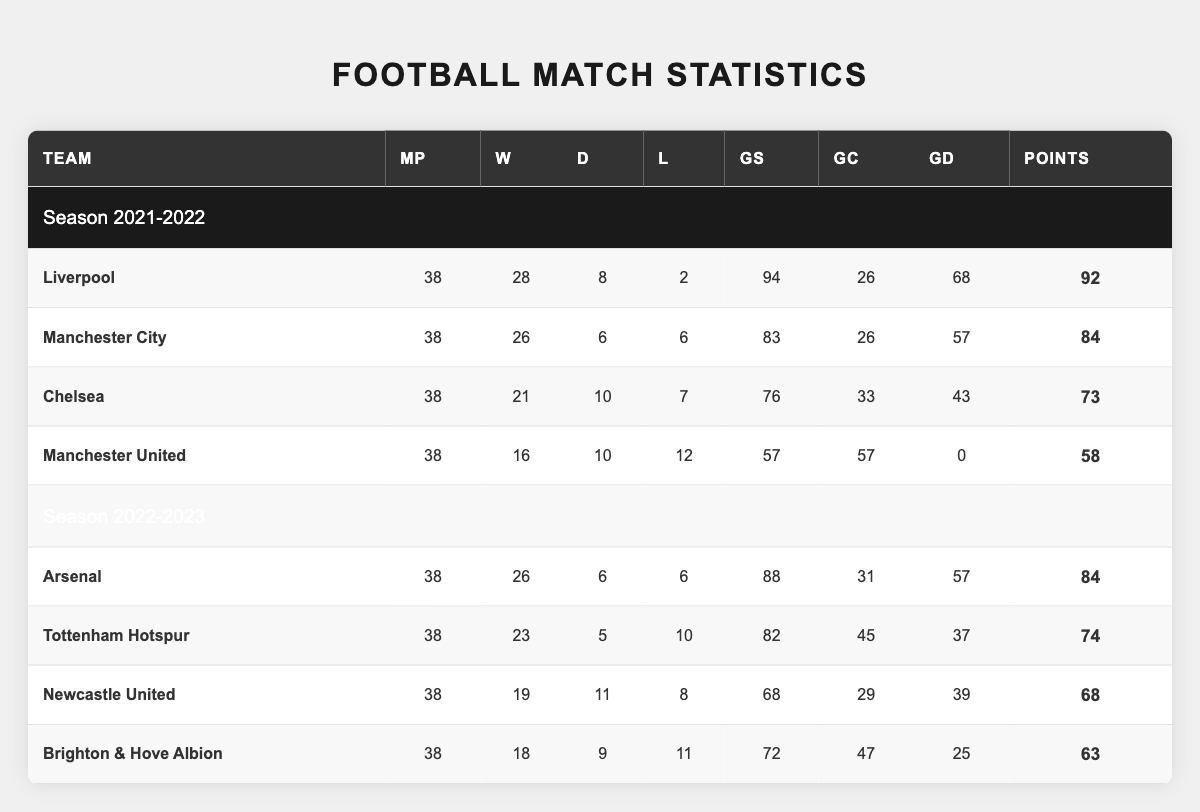What team scored the most goals in the 2021-2022 season? Liverpool scored 94 goals, which is higher than any other team in that season. Looking at the "GoalsScored" column for the 2021-2022 season, Liverpool is the top team.
Answer: Liverpool Which team had the highest points in the 2022-2023 season? Arsenal had 84 points, which is more than the points earned by any other team in the 2022-2023 season. Referring to the "Points" column, Arsenal tops the list for that season.
Answer: Arsenal How many matches did Chelsea play in the 2021-2022 season? Chelsea played 38 matches, as indicated in the "MatchesPlayed" column for that season. Each team's data reflects they played the same number of matches in a full season.
Answer: 38 What was the goal difference for Manchester United in the 2021-2022 season? Manchester United's goal difference was 0, as shown in the "GoalDifference" column for that season. This indicates their goals scored and conceded were equal.
Answer: 0 In which season did Liverpool achieve their highest number of wins? Liverpool achieved their highest number of wins in the 2021-2022 season with 28 wins. By comparing the "Wins" column for both seasons, this is the highest value they recorded.
Answer: 2021-2022 How many teams had a goal difference greater than 50 in the 2022-2023 season? Only one team, Arsenal, had a goal difference greater than 50, which was 57. Analyzing the "GoalDifference" column for the 2022-2023 season, no other teams exceeded this figure.
Answer: 1 What is the average number of wins across all teams in the 2021-2022 season? To find the average, sum the wins: (28 + 26 + 21 + 16) = 91; there are 4 teams, so divide by 4: 91 / 4 = 22.75. This calculation determines the average wins per team.
Answer: 22.75 Did Brighton & Hove Albion have a better performance than Newcastle United in terms of points? No, Brighton & Hove Albion had 63 points while Newcastle United had 68 points, which means Newcastle United performed better. Checking the "Points" column shows Newcastle had more points.
Answer: No Which team had the most draws in the 2021-2022 season? Chelsea had 10 draws, which is the highest number compared to other teams in that season. Referencing the "Draws" column for 2021-2022 confirms Chelsea's higher count.
Answer: Chelsea What is the total number of losses for both Manchester City and Chelsea in the 2021-2022 season? Adding the losses: Manchester City lost 6 times and Chelsea lost 7 times, totaling 13 losses (6 + 7 = 13). This aggregate gives the total losses for both teams in that season.
Answer: 13 